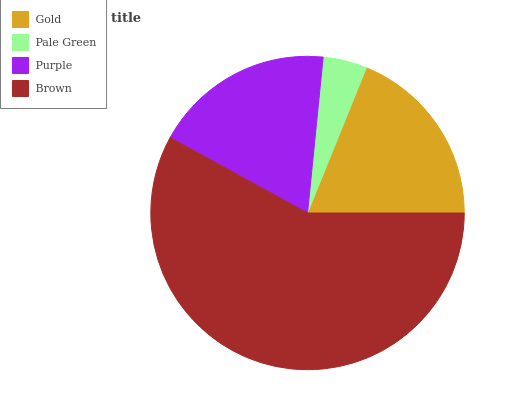Is Pale Green the minimum?
Answer yes or no. Yes. Is Brown the maximum?
Answer yes or no. Yes. Is Purple the minimum?
Answer yes or no. No. Is Purple the maximum?
Answer yes or no. No. Is Purple greater than Pale Green?
Answer yes or no. Yes. Is Pale Green less than Purple?
Answer yes or no. Yes. Is Pale Green greater than Purple?
Answer yes or no. No. Is Purple less than Pale Green?
Answer yes or no. No. Is Gold the high median?
Answer yes or no. Yes. Is Purple the low median?
Answer yes or no. Yes. Is Purple the high median?
Answer yes or no. No. Is Brown the low median?
Answer yes or no. No. 